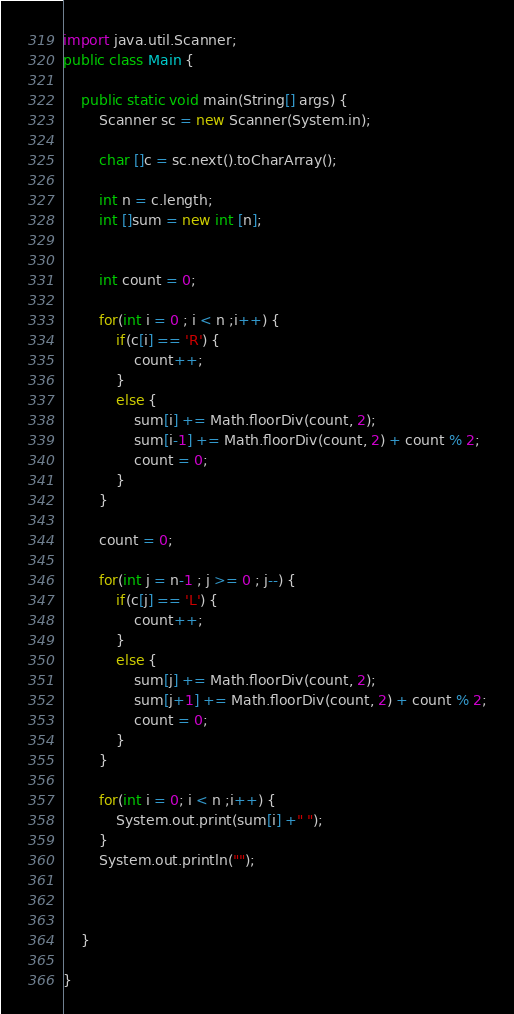<code> <loc_0><loc_0><loc_500><loc_500><_Java_>import java.util.Scanner;
public class Main {

	public static void main(String[] args) {
		Scanner sc = new Scanner(System.in);
		
		char []c = sc.next().toCharArray();
		
		int n = c.length;
		int []sum = new int [n];
		

		int count = 0;
		
		for(int i = 0 ; i < n ;i++) {
			if(c[i] == 'R') {
				count++;
			}
			else {
				sum[i] += Math.floorDiv(count, 2);
				sum[i-1] += Math.floorDiv(count, 2) + count % 2;
				count = 0;
			}
		}
		
		count = 0;
		
		for(int j = n-1 ; j >= 0 ; j--) {
			if(c[j] == 'L') {
				count++;
			}
			else {
				sum[j] += Math.floorDiv(count, 2);
				sum[j+1] += Math.floorDiv(count, 2) + count % 2;
				count = 0;
			}
		}
		
		for(int i = 0; i < n ;i++) {
			System.out.print(sum[i] +" ");
		}
		System.out.println("");
		
		

	}

}
</code> 